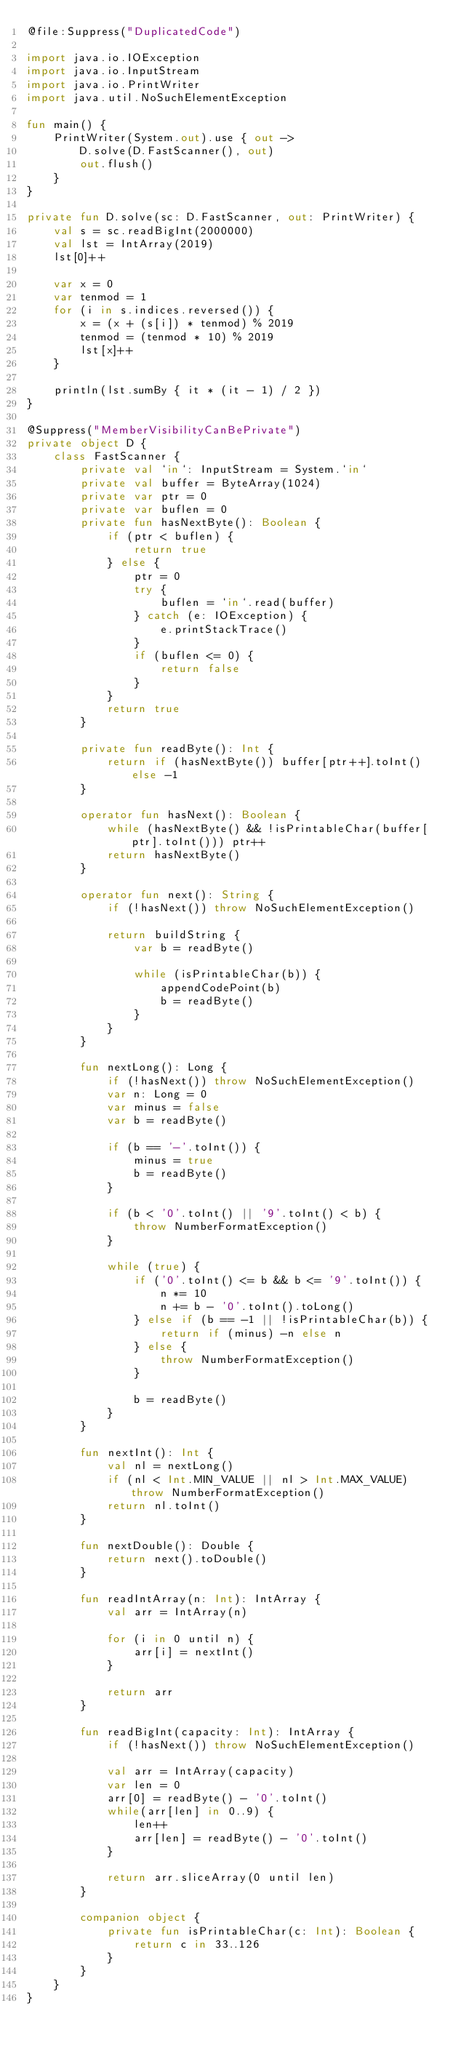Convert code to text. <code><loc_0><loc_0><loc_500><loc_500><_Kotlin_>@file:Suppress("DuplicatedCode")

import java.io.IOException
import java.io.InputStream
import java.io.PrintWriter
import java.util.NoSuchElementException

fun main() {
    PrintWriter(System.out).use { out ->
        D.solve(D.FastScanner(), out)
        out.flush()
    }
}

private fun D.solve(sc: D.FastScanner, out: PrintWriter) {
    val s = sc.readBigInt(2000000)
    val lst = IntArray(2019)
    lst[0]++

    var x = 0
    var tenmod = 1
    for (i in s.indices.reversed()) {
        x = (x + (s[i]) * tenmod) % 2019
        tenmod = (tenmod * 10) % 2019
        lst[x]++
    }

    println(lst.sumBy { it * (it - 1) / 2 })
}

@Suppress("MemberVisibilityCanBePrivate")
private object D {
    class FastScanner {
        private val `in`: InputStream = System.`in`
        private val buffer = ByteArray(1024)
        private var ptr = 0
        private var buflen = 0
        private fun hasNextByte(): Boolean {
            if (ptr < buflen) {
                return true
            } else {
                ptr = 0
                try {
                    buflen = `in`.read(buffer)
                } catch (e: IOException) {
                    e.printStackTrace()
                }
                if (buflen <= 0) {
                    return false
                }
            }
            return true
        }

        private fun readByte(): Int {
            return if (hasNextByte()) buffer[ptr++].toInt() else -1
        }

        operator fun hasNext(): Boolean {
            while (hasNextByte() && !isPrintableChar(buffer[ptr].toInt())) ptr++
            return hasNextByte()
        }

        operator fun next(): String {
            if (!hasNext()) throw NoSuchElementException()

            return buildString {
                var b = readByte()

                while (isPrintableChar(b)) {
                    appendCodePoint(b)
                    b = readByte()
                }
            }
        }

        fun nextLong(): Long {
            if (!hasNext()) throw NoSuchElementException()
            var n: Long = 0
            var minus = false
            var b = readByte()

            if (b == '-'.toInt()) {
                minus = true
                b = readByte()
            }

            if (b < '0'.toInt() || '9'.toInt() < b) {
                throw NumberFormatException()
            }

            while (true) {
                if ('0'.toInt() <= b && b <= '9'.toInt()) {
                    n *= 10
                    n += b - '0'.toInt().toLong()
                } else if (b == -1 || !isPrintableChar(b)) {
                    return if (minus) -n else n
                } else {
                    throw NumberFormatException()
                }

                b = readByte()
            }
        }

        fun nextInt(): Int {
            val nl = nextLong()
            if (nl < Int.MIN_VALUE || nl > Int.MAX_VALUE) throw NumberFormatException()
            return nl.toInt()
        }

        fun nextDouble(): Double {
            return next().toDouble()
        }

        fun readIntArray(n: Int): IntArray {
            val arr = IntArray(n)

            for (i in 0 until n) {
                arr[i] = nextInt()
            }

            return arr
        }

        fun readBigInt(capacity: Int): IntArray {
            if (!hasNext()) throw NoSuchElementException()

            val arr = IntArray(capacity)
            var len = 0
            arr[0] = readByte() - '0'.toInt()
            while(arr[len] in 0..9) {
                len++
                arr[len] = readByte() - '0'.toInt()
            }

            return arr.sliceArray(0 until len)
        }

        companion object {
            private fun isPrintableChar(c: Int): Boolean {
                return c in 33..126
            }
        }
    }
}
</code> 